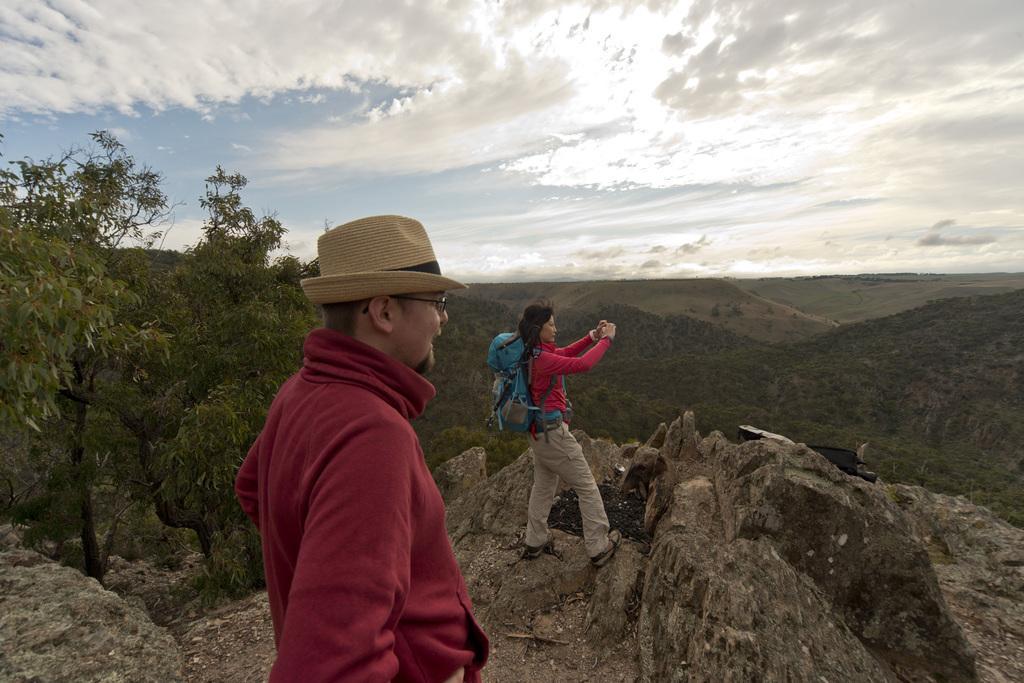Can you describe this image briefly? In this image we can see the mountains, one object on the rocks, some rocks, one woman wearing backpack standing, one man with hat standing, some trees, bushes, plants and grass on the ground. At the top there is the cloudy sky. 